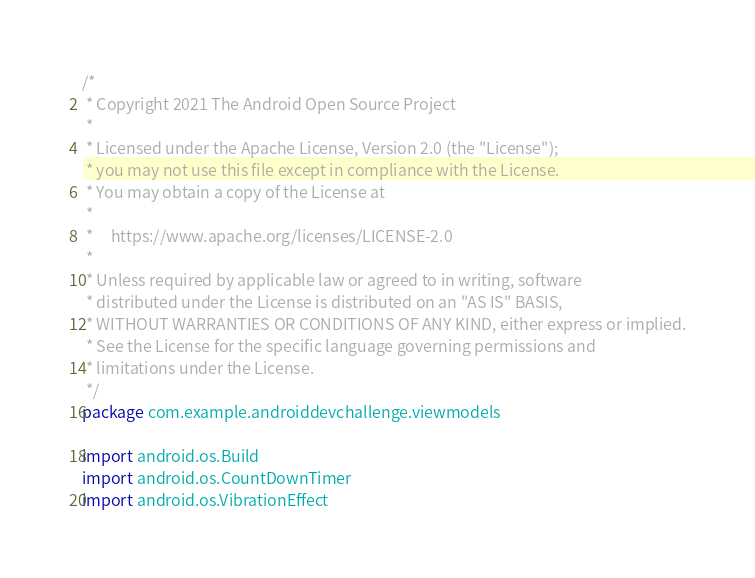Convert code to text. <code><loc_0><loc_0><loc_500><loc_500><_Kotlin_>/*
 * Copyright 2021 The Android Open Source Project
 *
 * Licensed under the Apache License, Version 2.0 (the "License");
 * you may not use this file except in compliance with the License.
 * You may obtain a copy of the License at
 *
 *     https://www.apache.org/licenses/LICENSE-2.0
 *
 * Unless required by applicable law or agreed to in writing, software
 * distributed under the License is distributed on an "AS IS" BASIS,
 * WITHOUT WARRANTIES OR CONDITIONS OF ANY KIND, either express or implied.
 * See the License for the specific language governing permissions and
 * limitations under the License.
 */
package com.example.androiddevchallenge.viewmodels

import android.os.Build
import android.os.CountDownTimer
import android.os.VibrationEffect</code> 